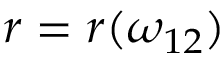Convert formula to latex. <formula><loc_0><loc_0><loc_500><loc_500>r = r ( \omega _ { 1 2 } )</formula> 